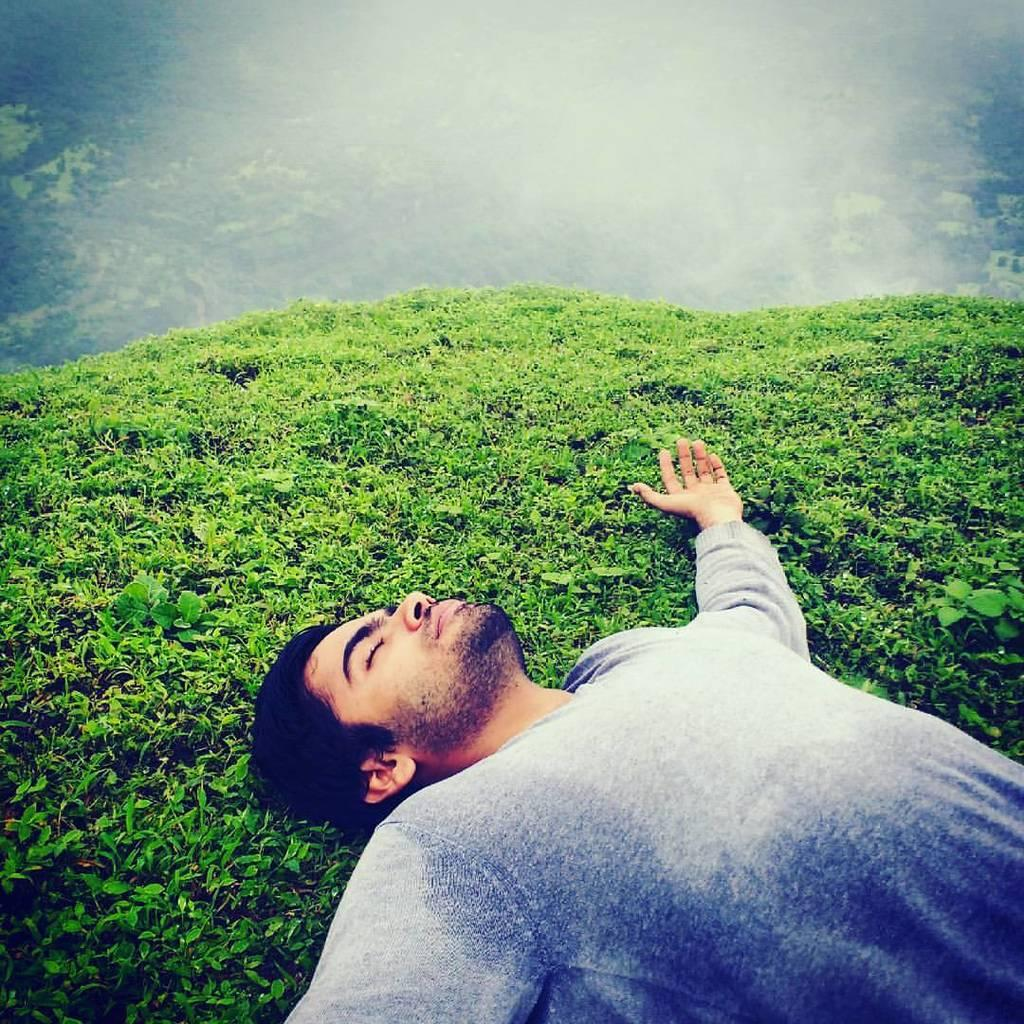What type of landscape is visible in the image? There is a hill view in the image. What is the person in the image doing? There is a person laying on the ground in the image. What is the weather like in the image? There is snow visible in the image, indicating a cold or wintry environment. What type of game is being played on the hill in the image? There is no game being played in the image; it only shows a person laying on the ground and a hill view with snow. 